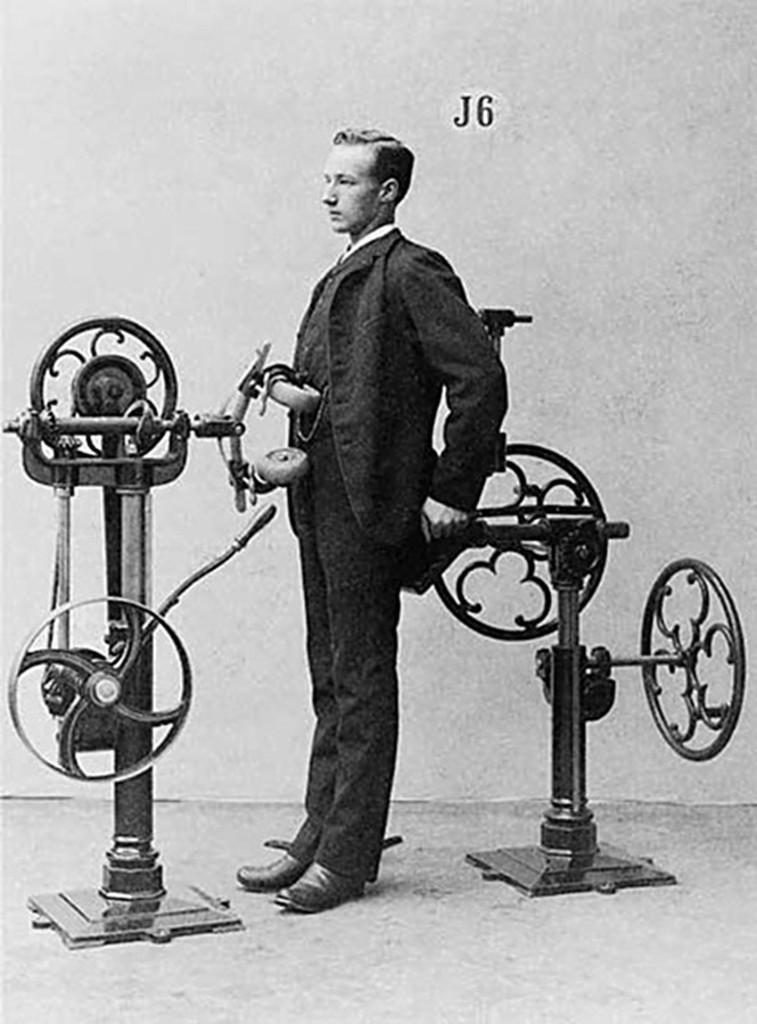What is the main object in the image? There is a machine in the image. Is there anyone else present in the image besides the machine? Yes, there is a person standing in the image. What is the color scheme of the image? The image is in black and white. What type of rice is being cooked in the machine in the image? There is no rice or cooking activity present in the image; it features a machine and a person. Can you hear the horn of a vehicle in the image? There is no mention of a vehicle or horn in the image, so it cannot be heard. 